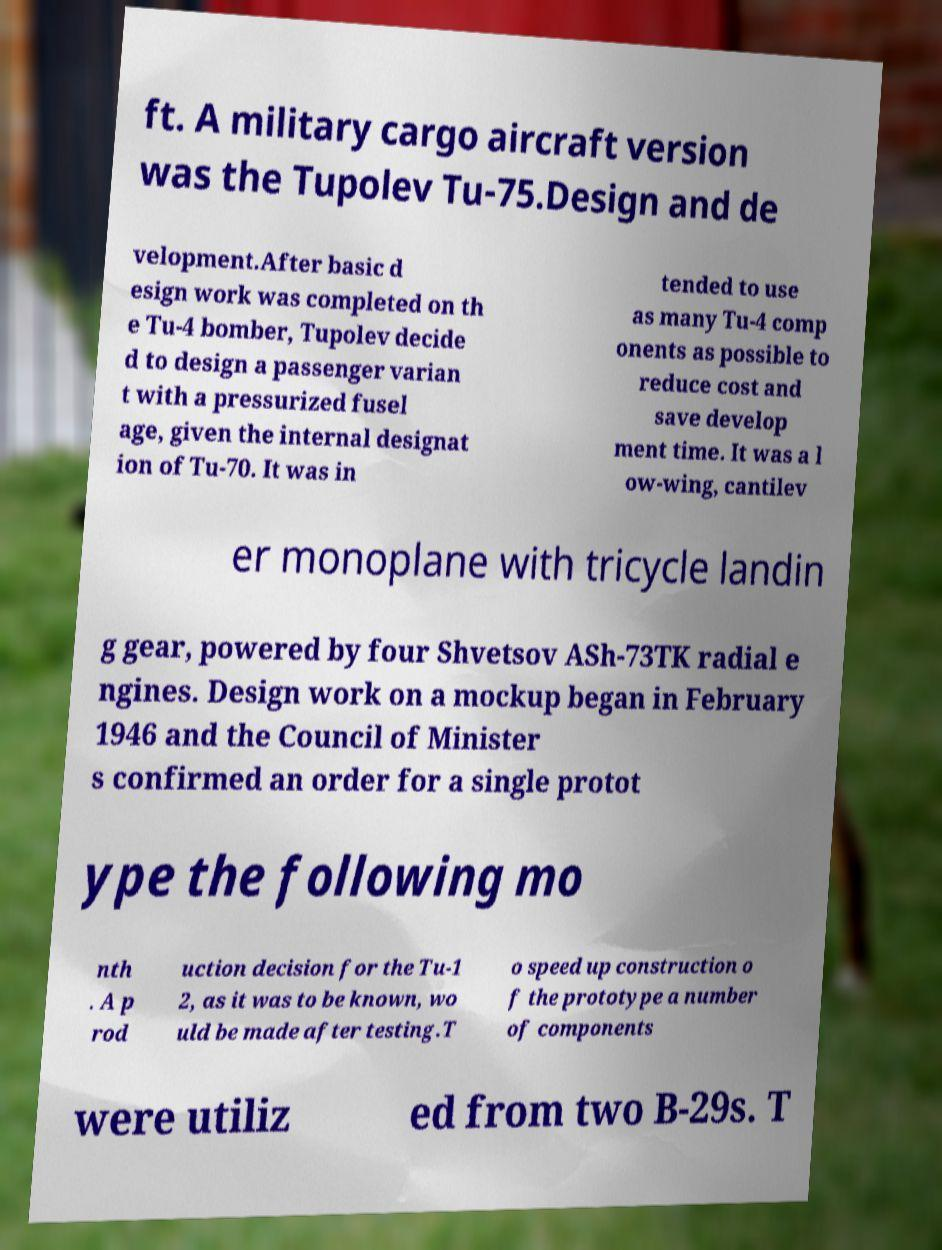I need the written content from this picture converted into text. Can you do that? ft. A military cargo aircraft version was the Tupolev Tu-75.Design and de velopment.After basic d esign work was completed on th e Tu-4 bomber, Tupolev decide d to design a passenger varian t with a pressurized fusel age, given the internal designat ion of Tu-70. It was in tended to use as many Tu-4 comp onents as possible to reduce cost and save develop ment time. It was a l ow-wing, cantilev er monoplane with tricycle landin g gear, powered by four Shvetsov ASh-73TK radial e ngines. Design work on a mockup began in February 1946 and the Council of Minister s confirmed an order for a single protot ype the following mo nth . A p rod uction decision for the Tu-1 2, as it was to be known, wo uld be made after testing.T o speed up construction o f the prototype a number of components were utiliz ed from two B-29s. T 